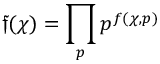<formula> <loc_0><loc_0><loc_500><loc_500>{ \mathfrak { f } } ( \chi ) = \prod _ { p } p ^ { f ( \chi , p ) }</formula> 